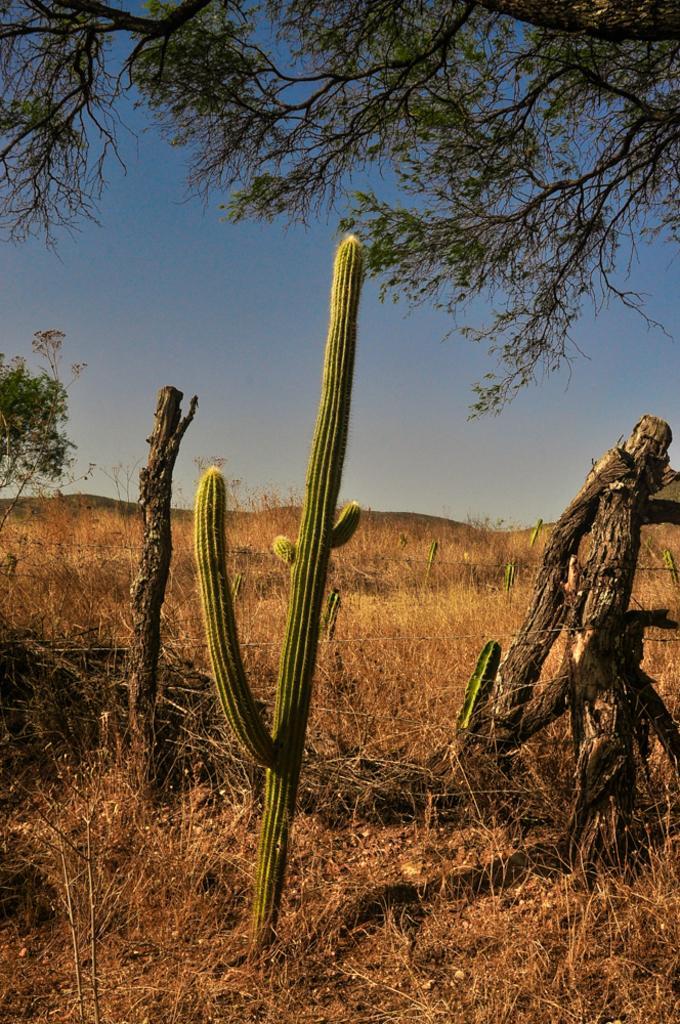In one or two sentences, can you explain what this image depicts? In this image there are some plants at bottom of this image and there are some grass as we can see in middle of this image and there is a tree at top of this image. 